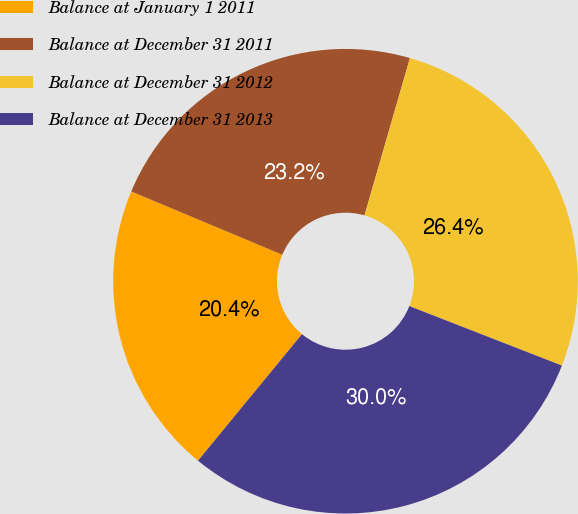Convert chart to OTSL. <chart><loc_0><loc_0><loc_500><loc_500><pie_chart><fcel>Balance at January 1 2011<fcel>Balance at December 31 2011<fcel>Balance at December 31 2012<fcel>Balance at December 31 2013<nl><fcel>20.37%<fcel>23.16%<fcel>26.44%<fcel>30.03%<nl></chart> 